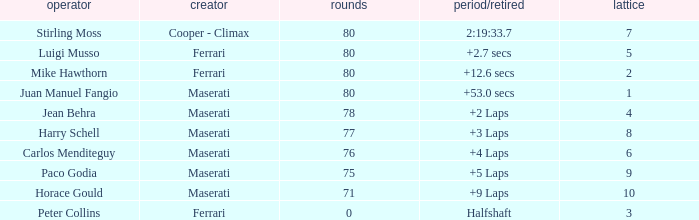Who was driving the Maserati with a Grid smaller than 6, and a Time/Retired of +2 laps? Jean Behra. 